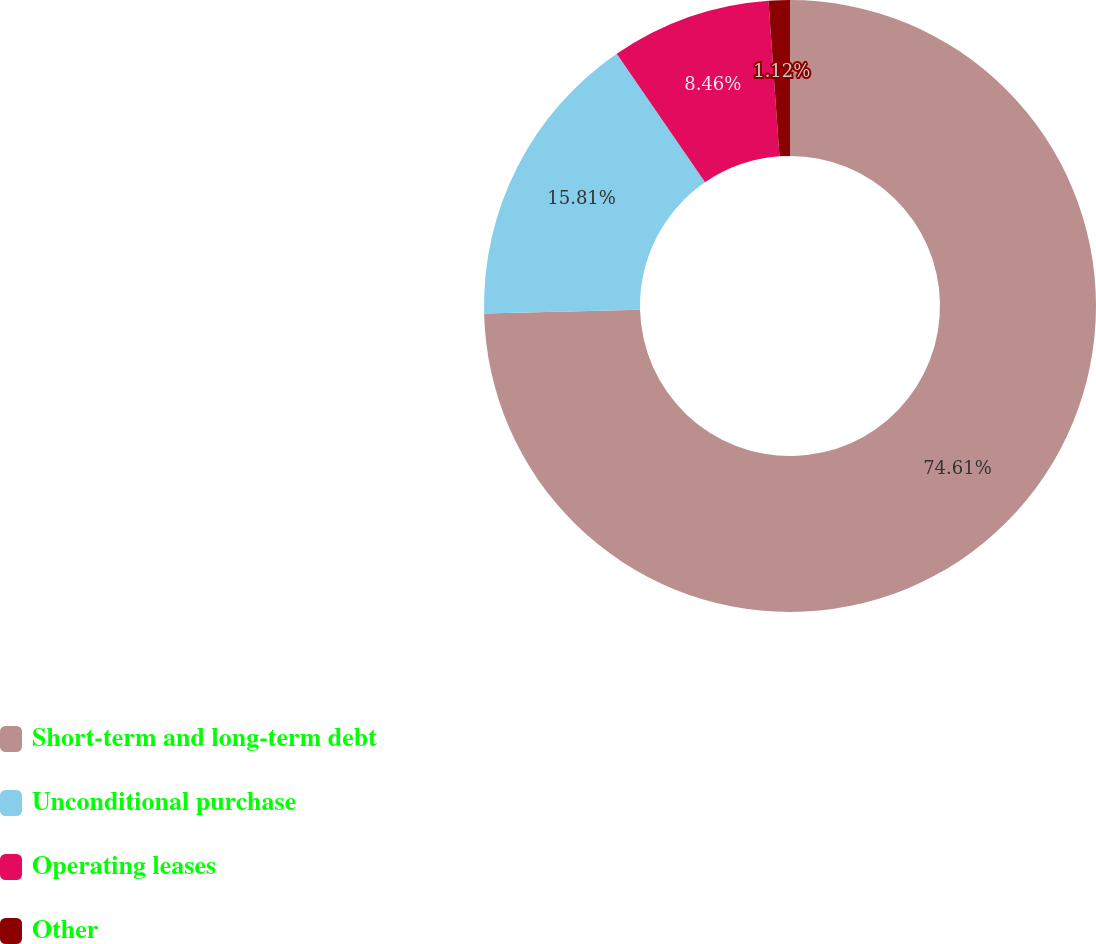<chart> <loc_0><loc_0><loc_500><loc_500><pie_chart><fcel>Short-term and long-term debt<fcel>Unconditional purchase<fcel>Operating leases<fcel>Other<nl><fcel>74.61%<fcel>15.81%<fcel>8.46%<fcel>1.12%<nl></chart> 